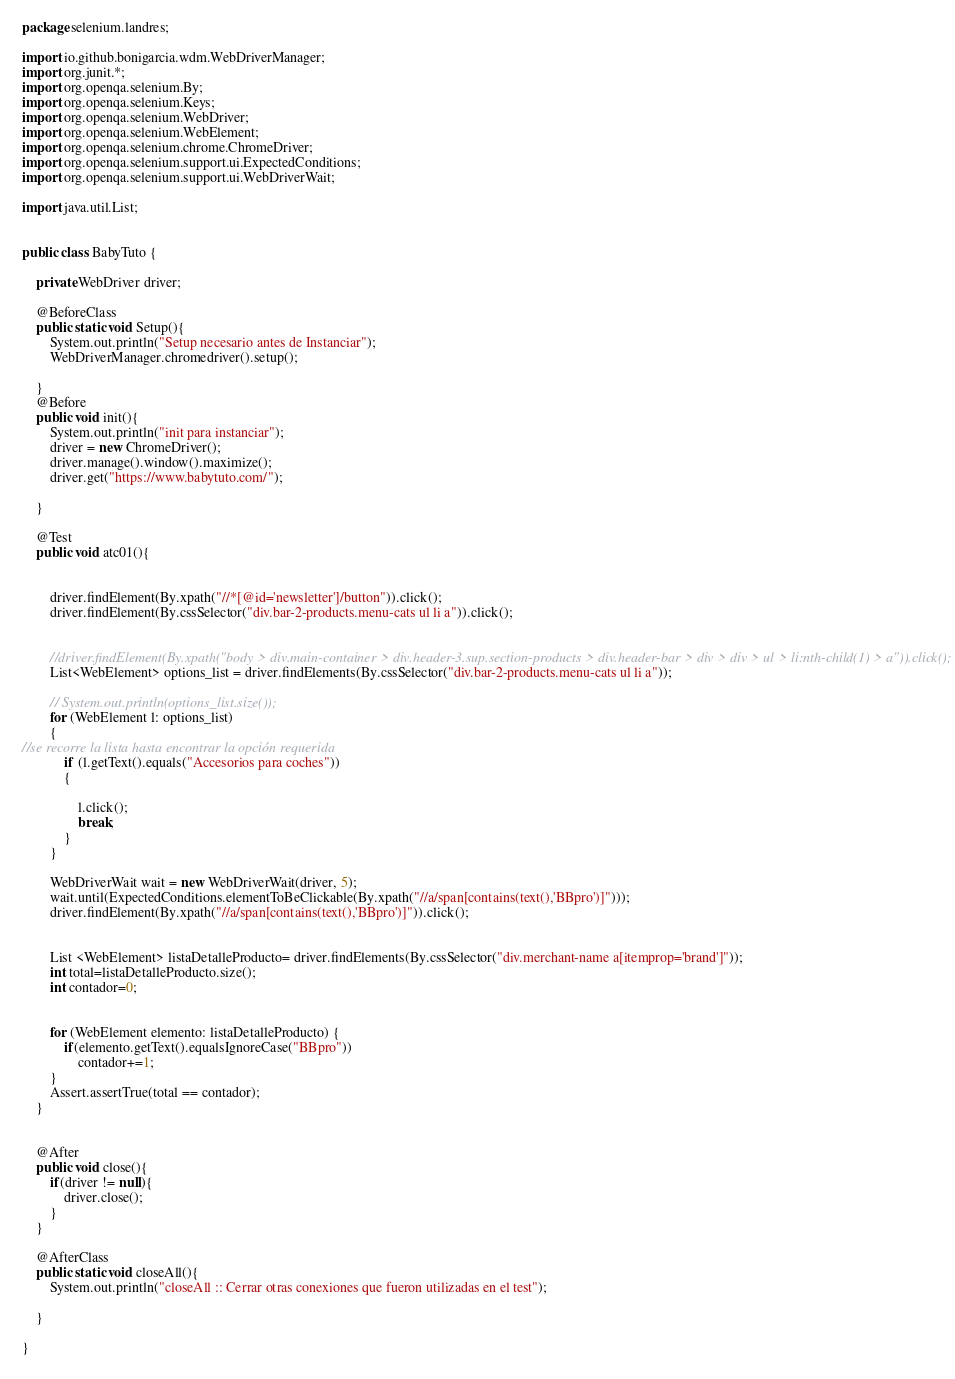<code> <loc_0><loc_0><loc_500><loc_500><_Java_>package selenium.landres;

import io.github.bonigarcia.wdm.WebDriverManager;
import org.junit.*;
import org.openqa.selenium.By;
import org.openqa.selenium.Keys;
import org.openqa.selenium.WebDriver;
import org.openqa.selenium.WebElement;
import org.openqa.selenium.chrome.ChromeDriver;
import org.openqa.selenium.support.ui.ExpectedConditions;
import org.openqa.selenium.support.ui.WebDriverWait;

import java.util.List;


public class BabyTuto {

    private WebDriver driver;

    @BeforeClass
    public static void Setup(){
        System.out.println("Setup necesario antes de Instanciar");
        WebDriverManager.chromedriver().setup();

    }
    @Before
    public void init(){
        System.out.println("init para instanciar");
        driver = new ChromeDriver();
        driver.manage().window().maximize();
        driver.get("https://www.babytuto.com/");

    }

    @Test
    public void atc01(){


        driver.findElement(By.xpath("//*[@id='newsletter']/button")).click();
        driver.findElement(By.cssSelector("div.bar-2-products.menu-cats ul li a")).click();


        //driver.findElement(By.xpath("body > div.main-container > div.header-3.sup.section-products > div.header-bar > div > div > ul > li:nth-child(1) > a")).click();
        List<WebElement> options_list = driver.findElements(By.cssSelector("div.bar-2-products.menu-cats ul li a"));

        // System.out.println(options_list.size());
        for (WebElement l: options_list)
        {
//se recorre la lista hasta encontrar la opción requerida
            if (l.getText().equals("Accesorios para coches"))
            {

                l.click();
                break;
            }
        }

        WebDriverWait wait = new WebDriverWait(driver, 5);
        wait.until(ExpectedConditions.elementToBeClickable(By.xpath("//a/span[contains(text(),'BBpro')]")));
        driver.findElement(By.xpath("//a/span[contains(text(),'BBpro')]")).click();


        List <WebElement> listaDetalleProducto= driver.findElements(By.cssSelector("div.merchant-name a[itemprop='brand']"));
        int total=listaDetalleProducto.size();
        int contador=0;


        for (WebElement elemento: listaDetalleProducto) {
            if(elemento.getText().equalsIgnoreCase("BBpro"))
                contador+=1;
        }
        Assert.assertTrue(total == contador);
    }


    @After
    public void close(){
        if(driver != null){
            driver.close();
        }
    }

    @AfterClass
    public static void closeAll(){
        System.out.println("closeAll :: Cerrar otras conexiones que fueron utilizadas en el test");

    }

}</code> 